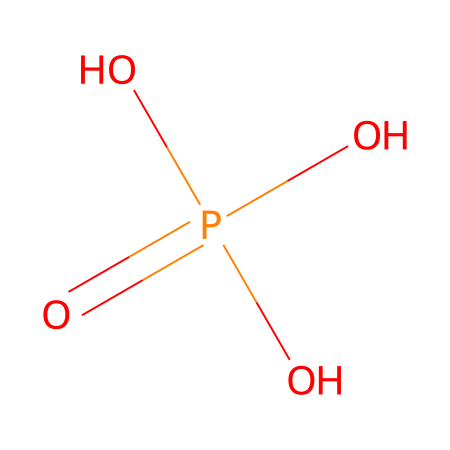What is the total number of oxygen atoms in this chemical? The chemical structure shows three hydroxyl groups (–OH) and one double-bonded oxygen (P=O). This gives a total of 4 oxygen atoms.
Answer: four How many phosphorus atoms are in this compound? The SMILES indicates one phosphorus atom (the central atom). No other phosphorus atoms are shown in the structure.
Answer: one What type of bonding is present between phosphorus and oxygen in this compound? The structure shows a double bond between phosphorus and one oxygen (P=O) and single bonds to three hydroxyl groups (P–O). This indicates covalent bonding.
Answer: covalent What is the geometric shape around the phosphorus atom? The presence of four substituents around the phosphorus atom (one double bond with oxygen and three single bonds with oxygen) suggests a tetrahedral geometry based on VSEPR theory.
Answer: tetrahedral Is this compound likely to be soluble in water? The presence of three hydroxyl groups contributes to polarity, making the compound hydrophilic and likely soluble in water.
Answer: yes What is the main functional group in this compound? The compound has phosphate groups with –OH functionalities, indicating that the functional group present is the phosphate group (PO4).
Answer: phosphate 